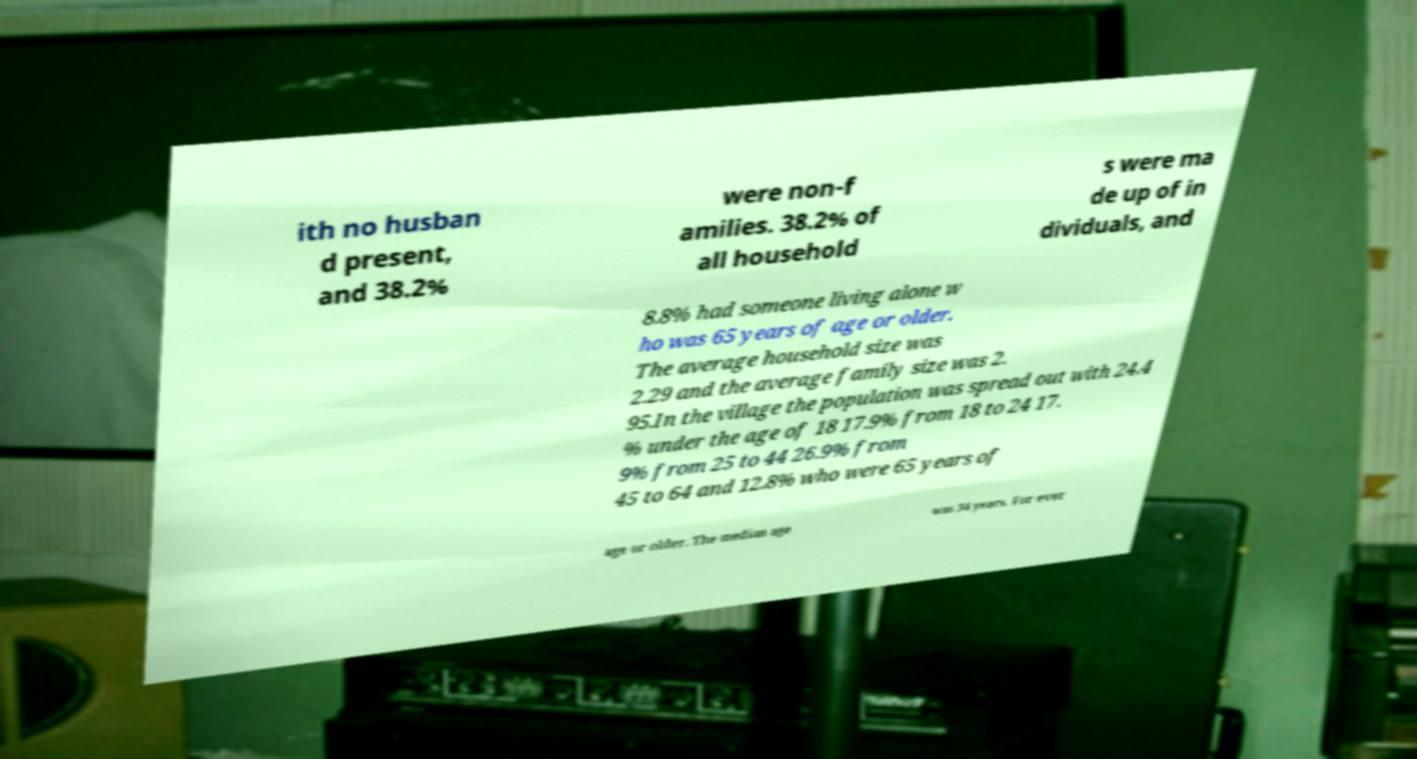Please read and relay the text visible in this image. What does it say? ith no husban d present, and 38.2% were non-f amilies. 38.2% of all household s were ma de up of in dividuals, and 8.8% had someone living alone w ho was 65 years of age or older. The average household size was 2.29 and the average family size was 2. 95.In the village the population was spread out with 24.4 % under the age of 18 17.9% from 18 to 24 17. 9% from 25 to 44 26.9% from 45 to 64 and 12.8% who were 65 years of age or older. The median age was 34 years. For ever 